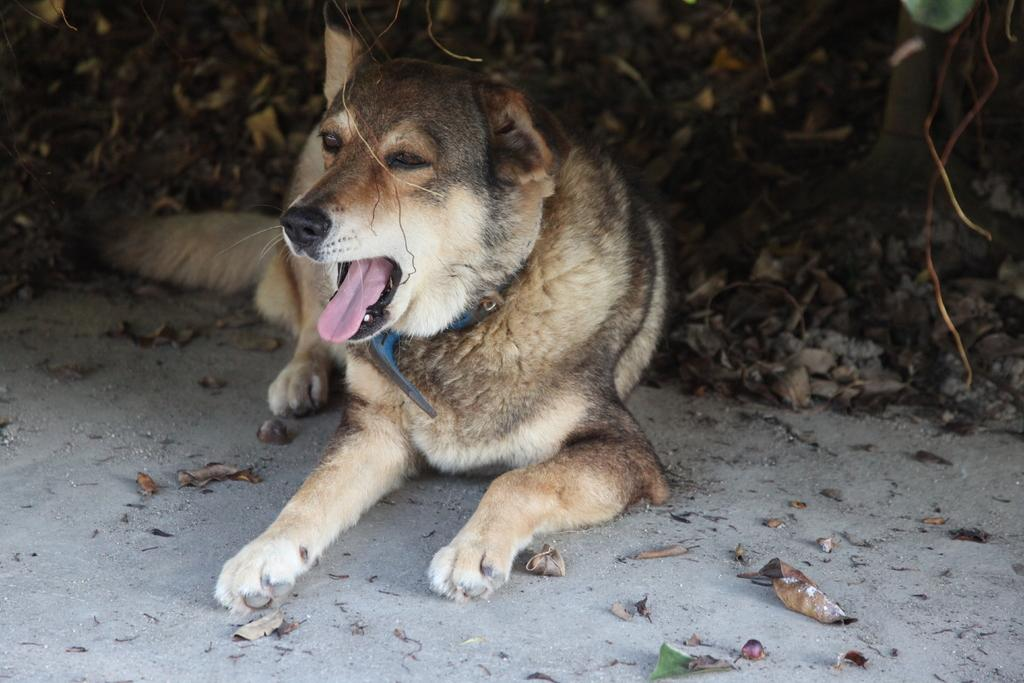What is the main subject in the middle of the image? There is a dog in the middle of the image. What can be seen at the bottom of the image? Dry leaves are present at the bottom of the image. What is visible on the ground in the image? The ground is visible in the image. What type of vegetation is visible in the background of the image? There are plants in the background of the image. What type of brush is being used by the dog in the image? There is no brush present in the image, and the dog is not using any tool or object. 